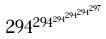Convert formula to latex. <formula><loc_0><loc_0><loc_500><loc_500>2 9 4 ^ { 2 9 4 ^ { 2 9 4 ^ { 2 9 4 ^ { 2 9 4 ^ { 2 9 7 } } } } }</formula> 